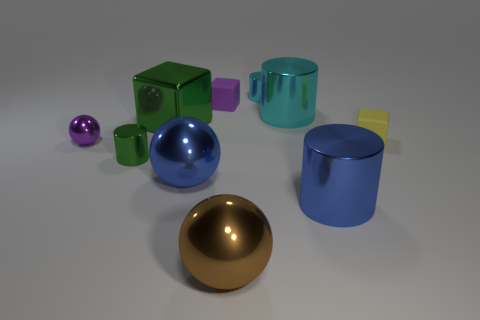There is a cyan cylinder that is to the right of the tiny metallic object right of the purple object right of the tiny green object; what size is it?
Your answer should be very brief. Large. There is a blue sphere; are there any shiny cylinders on the left side of it?
Keep it short and to the point. Yes. Is the size of the yellow matte thing the same as the shiny cylinder to the left of the brown sphere?
Your answer should be very brief. Yes. What number of other objects are the same material as the purple ball?
Provide a short and direct response. 7. There is a thing that is right of the purple matte object and behind the big cyan shiny cylinder; what is its shape?
Offer a very short reply. Cylinder. There is a thing behind the purple matte object; does it have the same size as the matte cube that is on the left side of the tiny yellow thing?
Your answer should be very brief. Yes. What is the shape of the large green object that is the same material as the brown thing?
Your response must be concise. Cube. What is the color of the cylinder that is behind the big cylinder behind the small block on the right side of the small cyan metal cylinder?
Your answer should be compact. Cyan. Is the number of spheres behind the small yellow matte cube less than the number of small matte cubes to the right of the tiny green metal object?
Give a very brief answer. Yes. Is the shape of the yellow thing the same as the big green thing?
Give a very brief answer. Yes. 